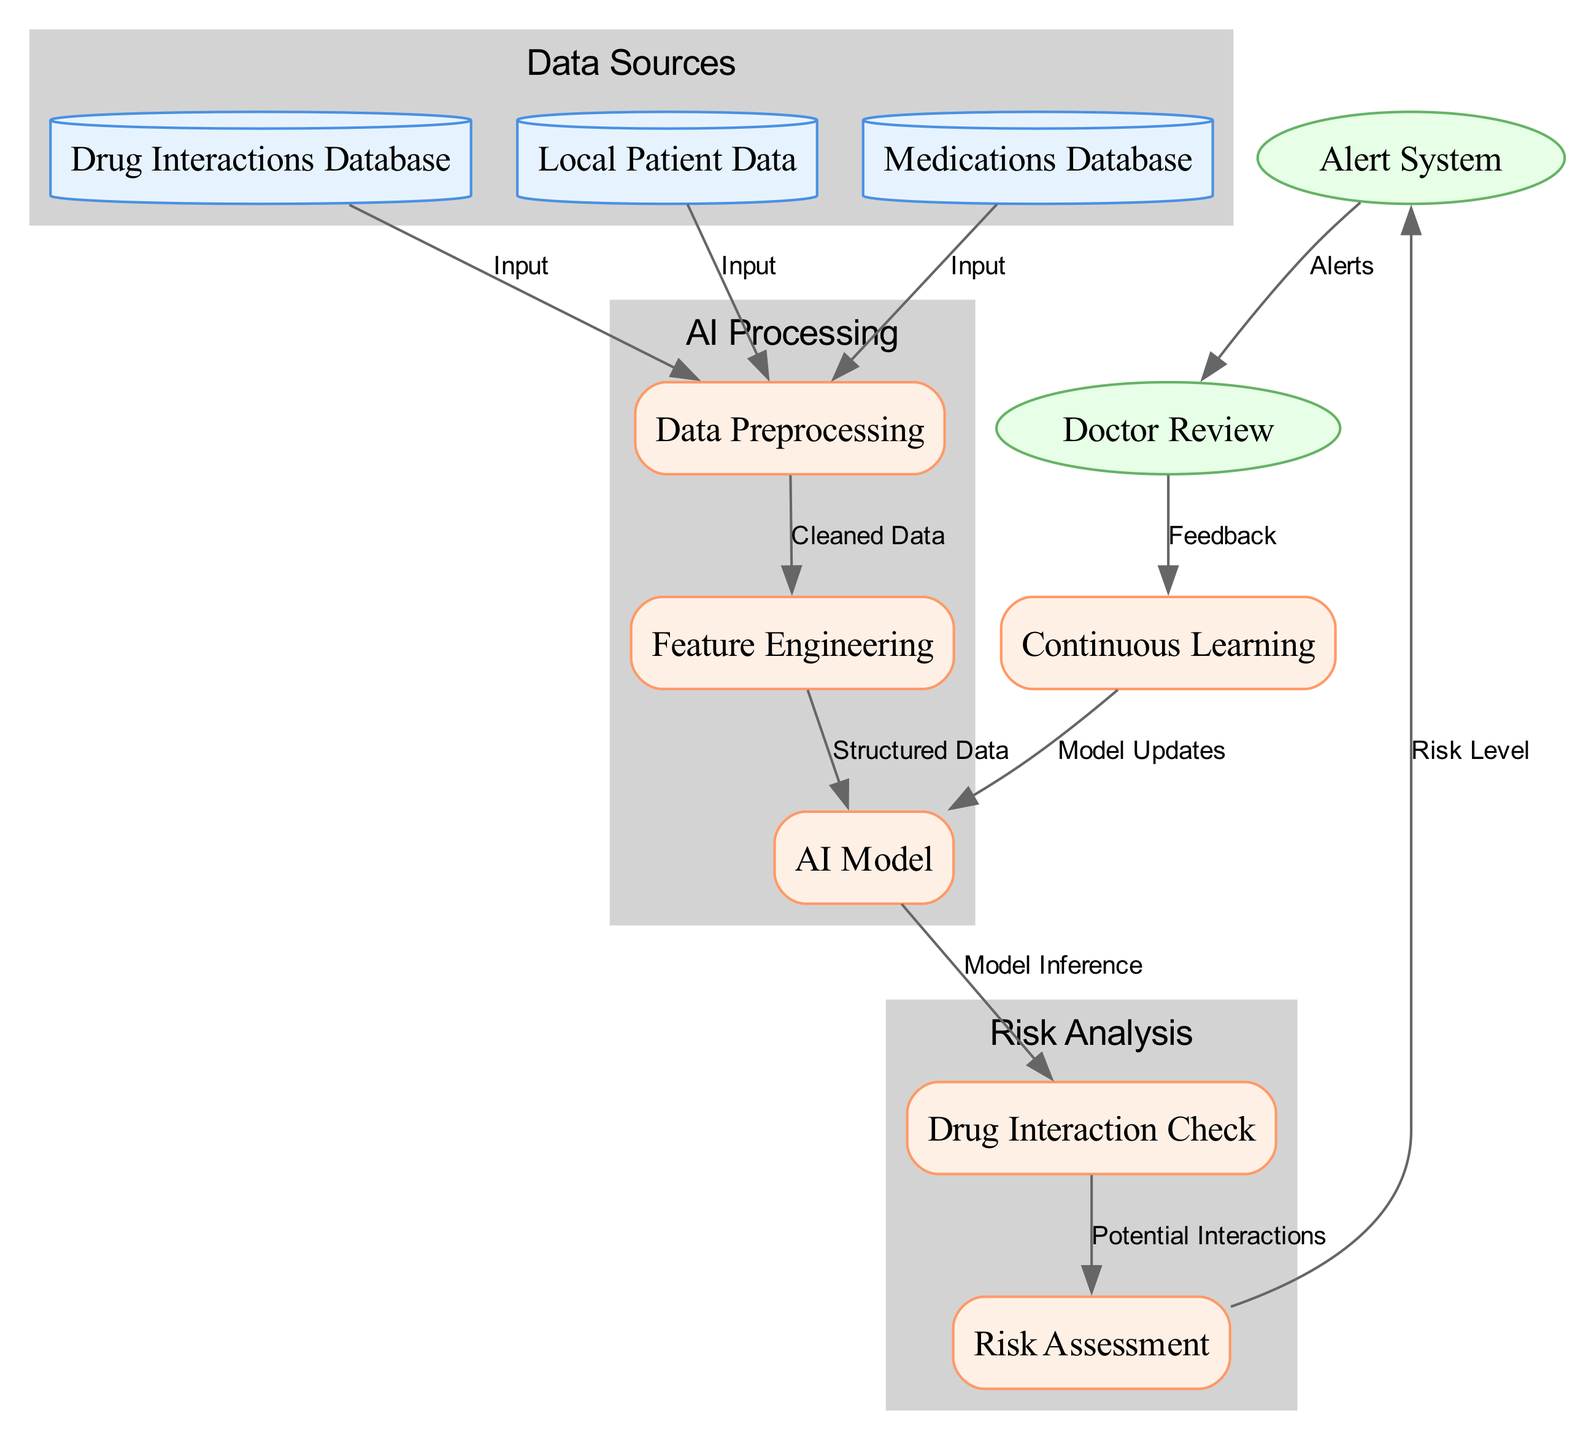What are the three main types of nodes in the diagram? The diagram contains data nodes, process nodes, and output nodes. Each node type serves a different role in the system's functionality.
Answer: data, process, output How many input nodes are there in the diagram? There are three input nodes: Local Patient Data, Medications Database, and Drug Interactions Database. Each input node provides necessary source information for the processing steps.
Answer: 3 What is the output after drug interaction check? The output after the Drug Interaction Check is the Potential Interactions that are assessed in the next step, which is Risk Assessment. This process involves analyzing the findings from the check.
Answer: Potential Interactions Which node connects to the Doctor Review node? The node that connects to the Doctor Review node is the Alert System, which generates alerts based on the risk assessment to inform the doctor for further action.
Answer: Alert System What type of data does the AI Model receive? The AI Model receives Structured Data that has undergone feature engineering, indicating that the data is organized and formatted appropriately for model inference.
Answer: Structured Data What feedback does the Doctor Review node provide? The Doctor Review node provides Feedback which is used in the Continuous Learning process to update the AI Model, improving its predictions and assessments over time.
Answer: Feedback How many processes are involved in the system? The system has six processes: Data Preprocessing, Feature Engineering, AI Model, Drug Interaction Check, Risk Assessment, and Continuous Learning. Each process contributes to transforming input data and yielding output.
Answer: 6 What is the purpose of the Continuous Learning process? The Continuous Learning process is designed to take feedback from the Doctor Review node and use it to make Model Updates, facilitating ongoing improvement in the AI Model's performance.
Answer: Model Updates Which type of node is the Drug Interaction Check? The Drug Interaction Check is classified as a process node, which indicates that it performs a specific function within the overall workflow of the diagram.
Answer: process 